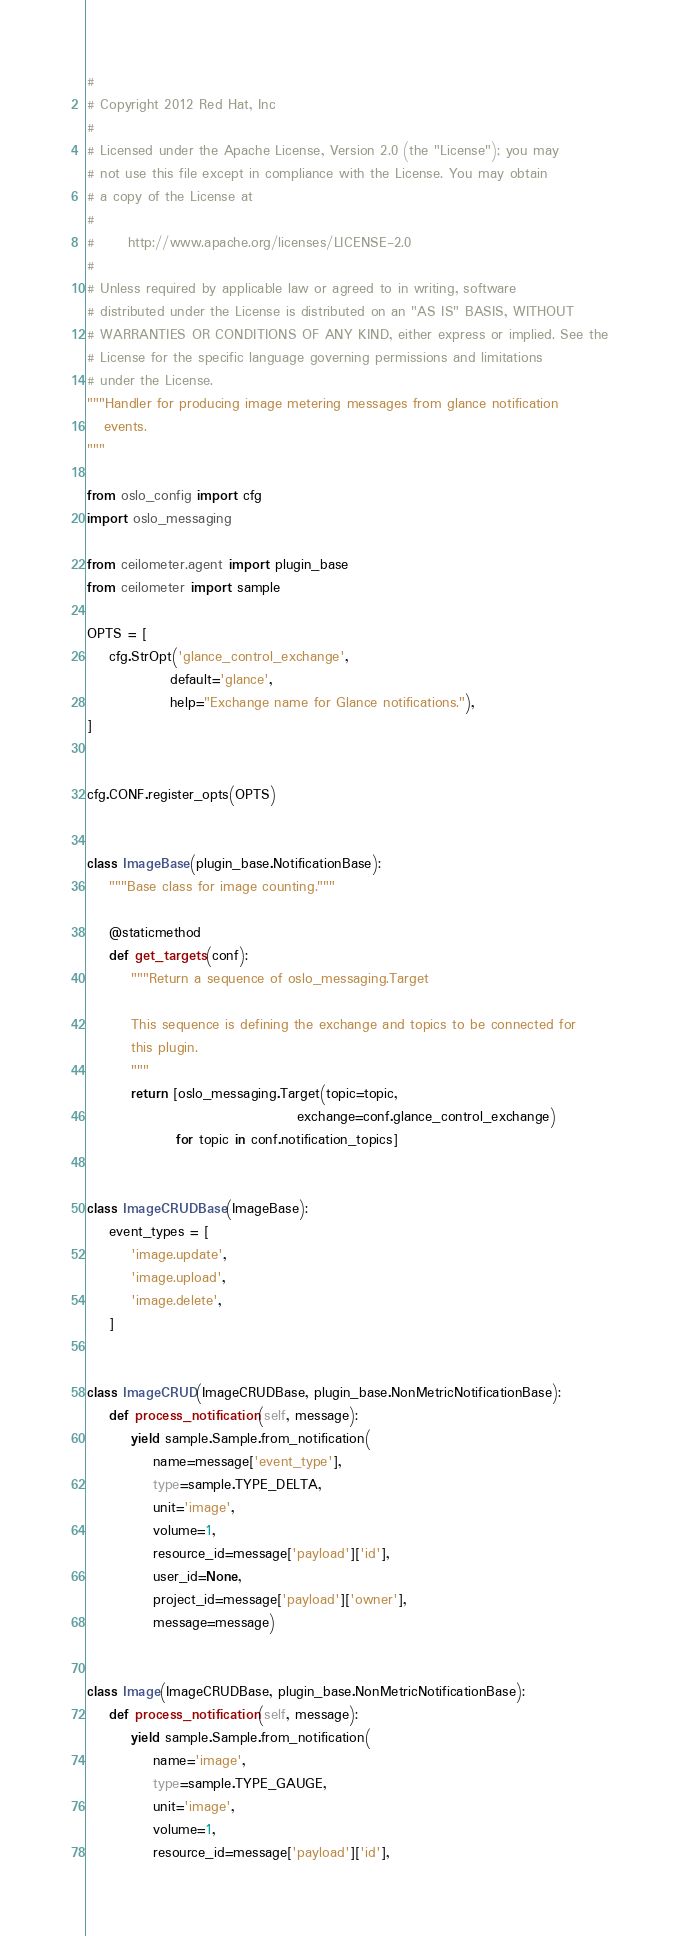Convert code to text. <code><loc_0><loc_0><loc_500><loc_500><_Python_>#
# Copyright 2012 Red Hat, Inc
#
# Licensed under the Apache License, Version 2.0 (the "License"); you may
# not use this file except in compliance with the License. You may obtain
# a copy of the License at
#
#      http://www.apache.org/licenses/LICENSE-2.0
#
# Unless required by applicable law or agreed to in writing, software
# distributed under the License is distributed on an "AS IS" BASIS, WITHOUT
# WARRANTIES OR CONDITIONS OF ANY KIND, either express or implied. See the
# License for the specific language governing permissions and limitations
# under the License.
"""Handler for producing image metering messages from glance notification
   events.
"""

from oslo_config import cfg
import oslo_messaging

from ceilometer.agent import plugin_base
from ceilometer import sample

OPTS = [
    cfg.StrOpt('glance_control_exchange',
               default='glance',
               help="Exchange name for Glance notifications."),
]


cfg.CONF.register_opts(OPTS)


class ImageBase(plugin_base.NotificationBase):
    """Base class for image counting."""

    @staticmethod
    def get_targets(conf):
        """Return a sequence of oslo_messaging.Target

        This sequence is defining the exchange and topics to be connected for
        this plugin.
        """
        return [oslo_messaging.Target(topic=topic,
                                      exchange=conf.glance_control_exchange)
                for topic in conf.notification_topics]


class ImageCRUDBase(ImageBase):
    event_types = [
        'image.update',
        'image.upload',
        'image.delete',
    ]


class ImageCRUD(ImageCRUDBase, plugin_base.NonMetricNotificationBase):
    def process_notification(self, message):
        yield sample.Sample.from_notification(
            name=message['event_type'],
            type=sample.TYPE_DELTA,
            unit='image',
            volume=1,
            resource_id=message['payload']['id'],
            user_id=None,
            project_id=message['payload']['owner'],
            message=message)


class Image(ImageCRUDBase, plugin_base.NonMetricNotificationBase):
    def process_notification(self, message):
        yield sample.Sample.from_notification(
            name='image',
            type=sample.TYPE_GAUGE,
            unit='image',
            volume=1,
            resource_id=message['payload']['id'],</code> 